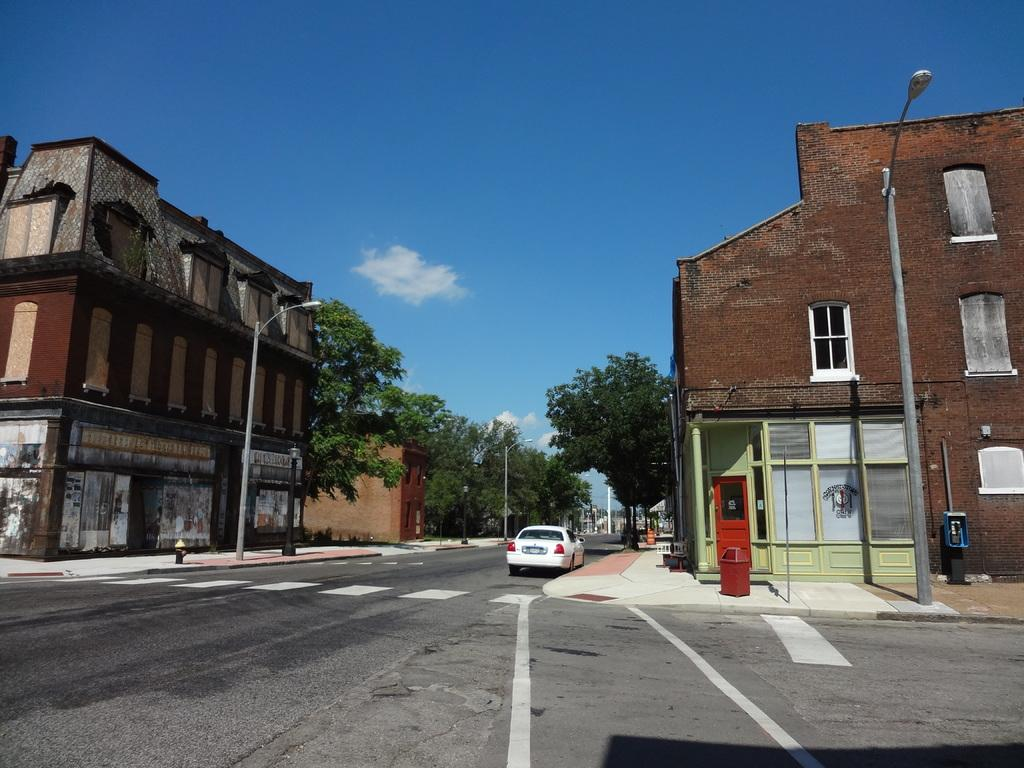What type of vehicle can be seen on the road in the image? There is a car on the road in the image. What structures are present in the image? There are poles, trees, buildings, boards, and a bin visible in the image. What features can be seen on the buildings? There are lights and windows on the buildings in the image. What is visible in the background of the image? The sky is visible in the background of the image, with clouds present. What type of ball is being distributed by the car in the image? There is no ball present in the image, and the car is not distributing anything. What type of rice is visible in the image? There is no rice present in the image. 